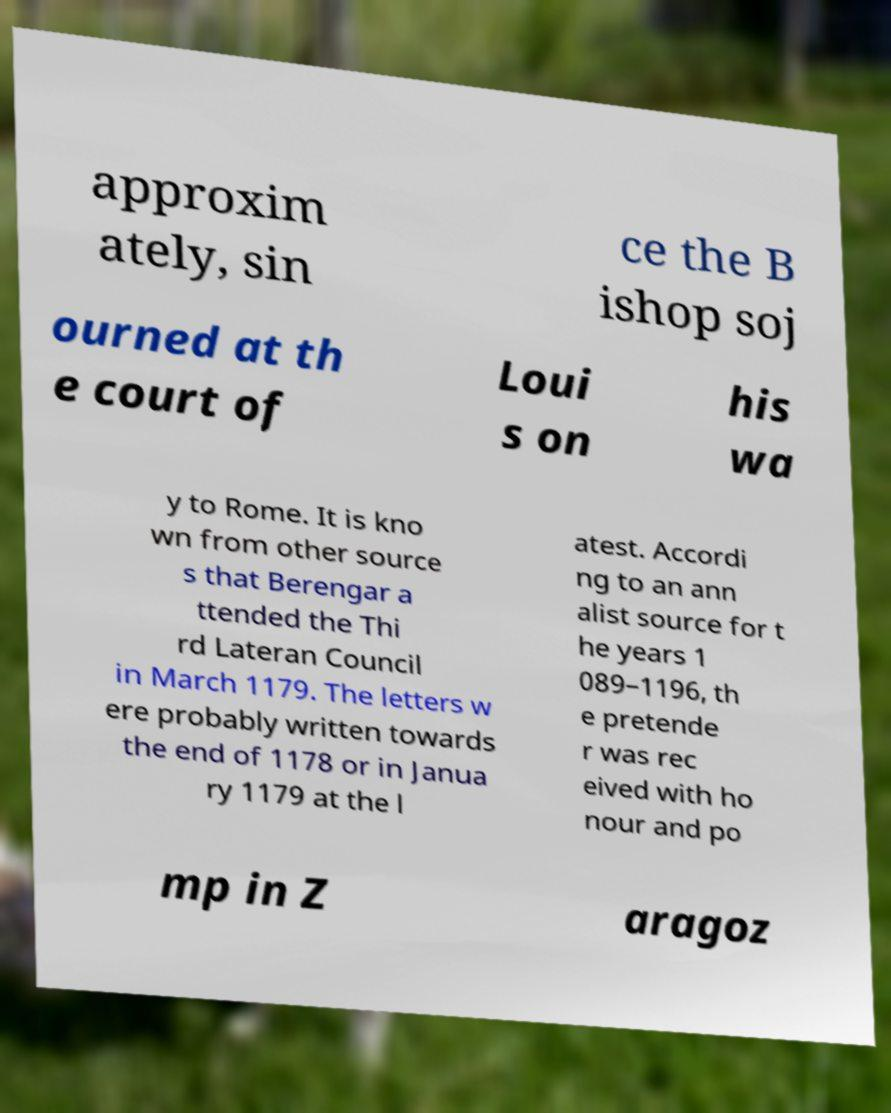Please read and relay the text visible in this image. What does it say? approxim ately, sin ce the B ishop soj ourned at th e court of Loui s on his wa y to Rome. It is kno wn from other source s that Berengar a ttended the Thi rd Lateran Council in March 1179. The letters w ere probably written towards the end of 1178 or in Janua ry 1179 at the l atest. Accordi ng to an ann alist source for t he years 1 089–1196, th e pretende r was rec eived with ho nour and po mp in Z aragoz 